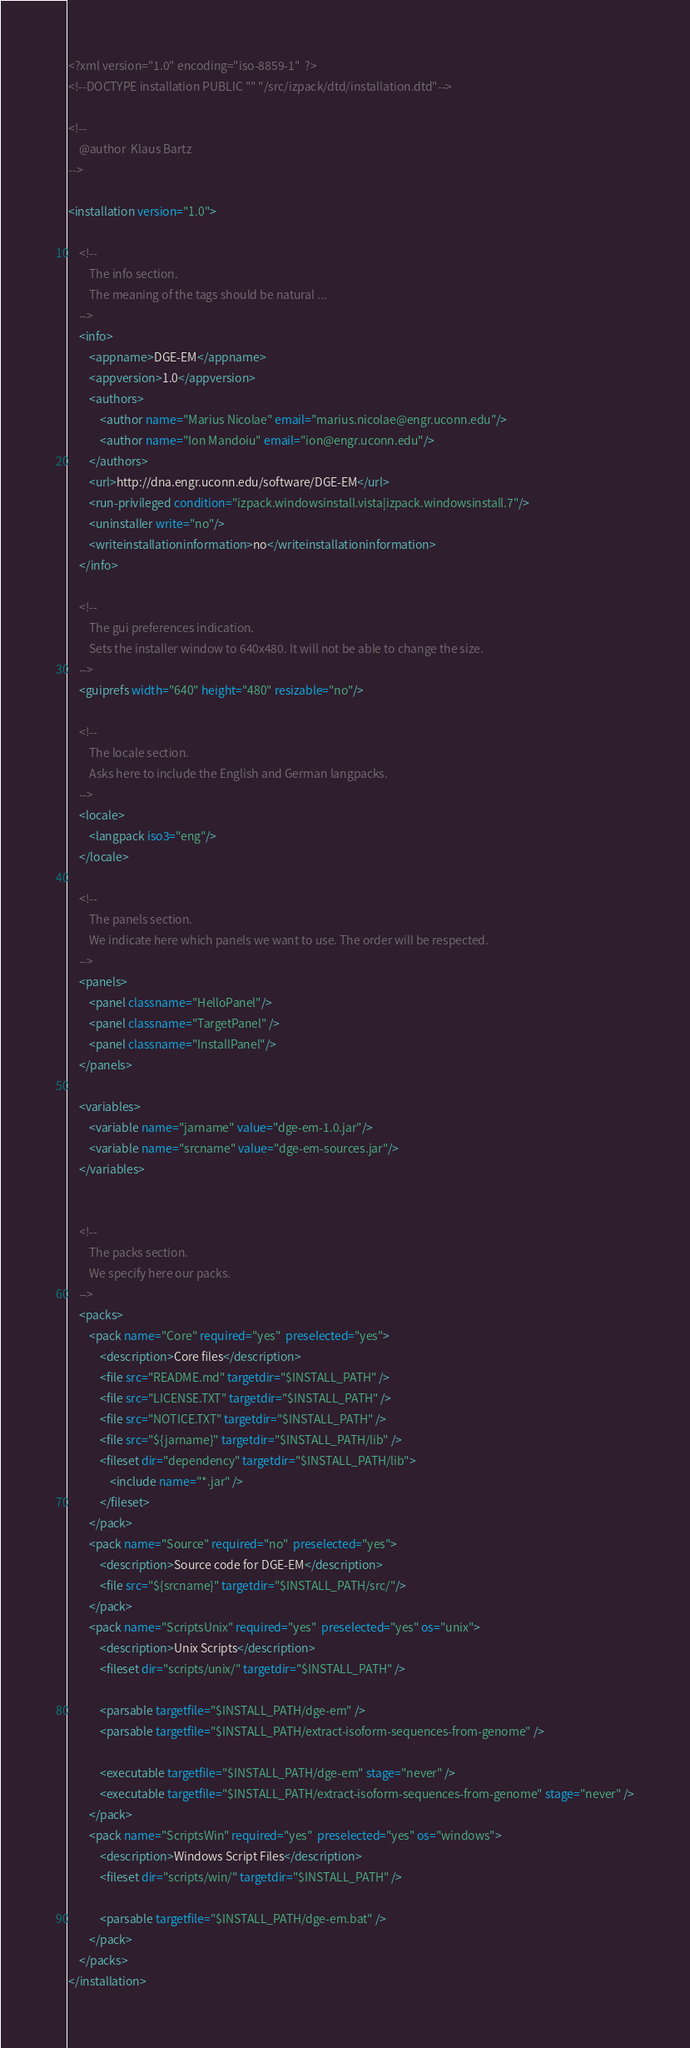Convert code to text. <code><loc_0><loc_0><loc_500><loc_500><_XML_><?xml version="1.0" encoding="iso-8859-1"  ?>
<!--DOCTYPE installation PUBLIC "" "/src/izpack/dtd/installation.dtd"-->

<!-- 
	@author  Klaus Bartz
-->

<installation version="1.0">

    <!-- 
        The info section.
        The meaning of the tags should be natural ...
    -->
    <info>
        <appname>DGE-EM</appname>
        <appversion>1.0</appversion>
        <authors>
            <author name="Marius Nicolae" email="marius.nicolae@engr.uconn.edu"/>
            <author name="Ion Mandoiu" email="ion@engr.uconn.edu"/>
        </authors>
        <url>http://dna.engr.uconn.edu/software/DGE-EM</url>
		<run-privileged condition="izpack.windowsinstall.vista|izpack.windowsinstall.7"/>
		<uninstaller write="no"/>
		<writeinstallationinformation>no</writeinstallationinformation>
    </info>

    <!-- 
        The gui preferences indication.
        Sets the installer window to 640x480. It will not be able to change the size.
    -->
    <guiprefs width="640" height="480" resizable="no"/>

    <!-- 
        The locale section.
        Asks here to include the English and German langpacks.
    -->
    <locale>
        <langpack iso3="eng"/>
    </locale>

    <!-- 
        The panels section.
        We indicate here which panels we want to use. The order will be respected.
    -->
    <panels>
        <panel classname="HelloPanel"/>
        <panel classname="TargetPanel" />
        <panel classname="InstallPanel"/>
    </panels>

	<variables>
		<variable name="jarname" value="dge-em-1.0.jar"/>
		<variable name="srcname" value="dge-em-sources.jar"/>
	</variables>

   
    <!-- 
        The packs section.
        We specify here our packs.
    -->
    <packs>
        <pack name="Core" required="yes"  preselected="yes">
            <description>Core files</description>
            <file src="README.md" targetdir="$INSTALL_PATH" />
            <file src="LICENSE.TXT" targetdir="$INSTALL_PATH" />
            <file src="NOTICE.TXT" targetdir="$INSTALL_PATH" />
            <file src="${jarname}" targetdir="$INSTALL_PATH/lib" />     
            <fileset dir="dependency" targetdir="$INSTALL_PATH/lib">
                <include name="*.jar" />
            </fileset>
        </pack>
        <pack name="Source" required="no"  preselected="yes">
            <description>Source code for DGE-EM</description>
            <file src="${srcname}" targetdir="$INSTALL_PATH/src/"/>
        </pack>
        <pack name="ScriptsUnix" required="yes"  preselected="yes" os="unix">
            <description>Unix Scripts</description>
            <fileset dir="scripts/unix/" targetdir="$INSTALL_PATH" />

			<parsable targetfile="$INSTALL_PATH/dge-em" />
			<parsable targetfile="$INSTALL_PATH/extract-isoform-sequences-from-genome" />

			<executable targetfile="$INSTALL_PATH/dge-em" stage="never" />
			<executable targetfile="$INSTALL_PATH/extract-isoform-sequences-from-genome" stage="never" />
        </pack>
		<pack name="ScriptsWin" required="yes"  preselected="yes" os="windows">
            <description>Windows Script Files</description>
            <fileset dir="scripts/win/" targetdir="$INSTALL_PATH" />

			<parsable targetfile="$INSTALL_PATH/dge-em.bat" />
        </pack>
    </packs>
</installation>
</code> 